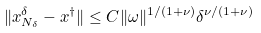Convert formula to latex. <formula><loc_0><loc_0><loc_500><loc_500>\| x _ { N _ { \delta } } ^ { \delta } - x ^ { \dag } \| \leq C \| \omega \| ^ { 1 / ( 1 + \nu ) } \delta ^ { \nu / ( 1 + \nu ) }</formula> 